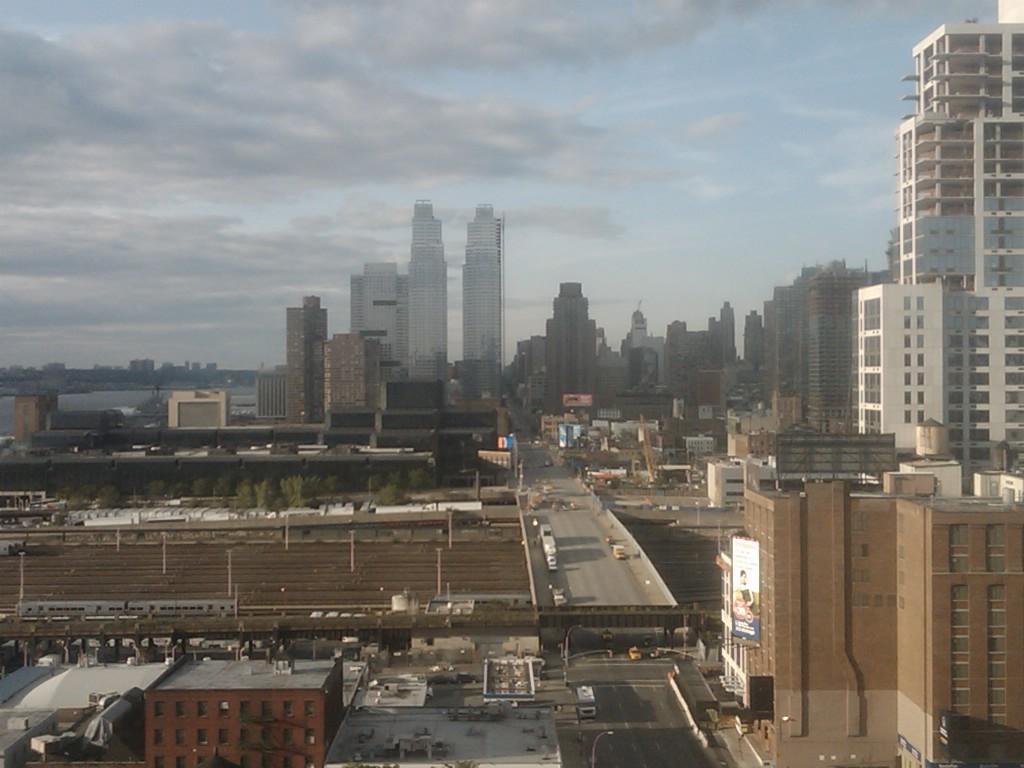In one or two sentences, can you explain what this image depicts? In this image we can see few buildings, few vehicles on the road, a bridge, trees, poles and the sky with clouds on the top. 